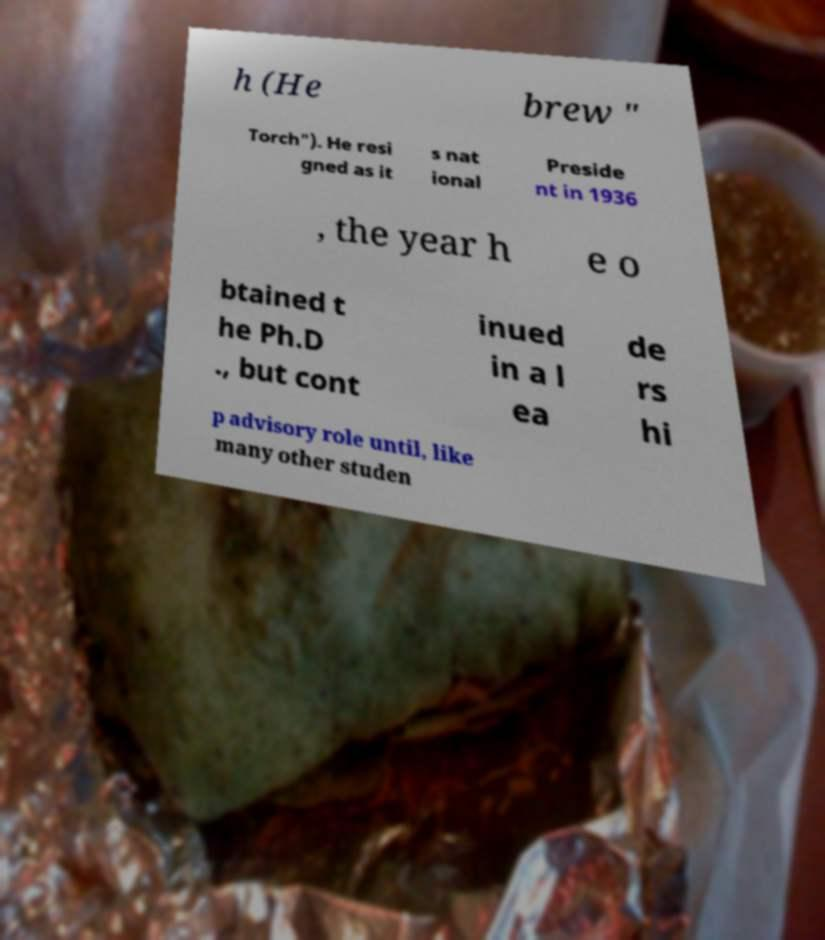Please identify and transcribe the text found in this image. h (He brew " Torch"). He resi gned as it s nat ional Preside nt in 1936 , the year h e o btained t he Ph.D ., but cont inued in a l ea de rs hi p advisory role until, like many other studen 